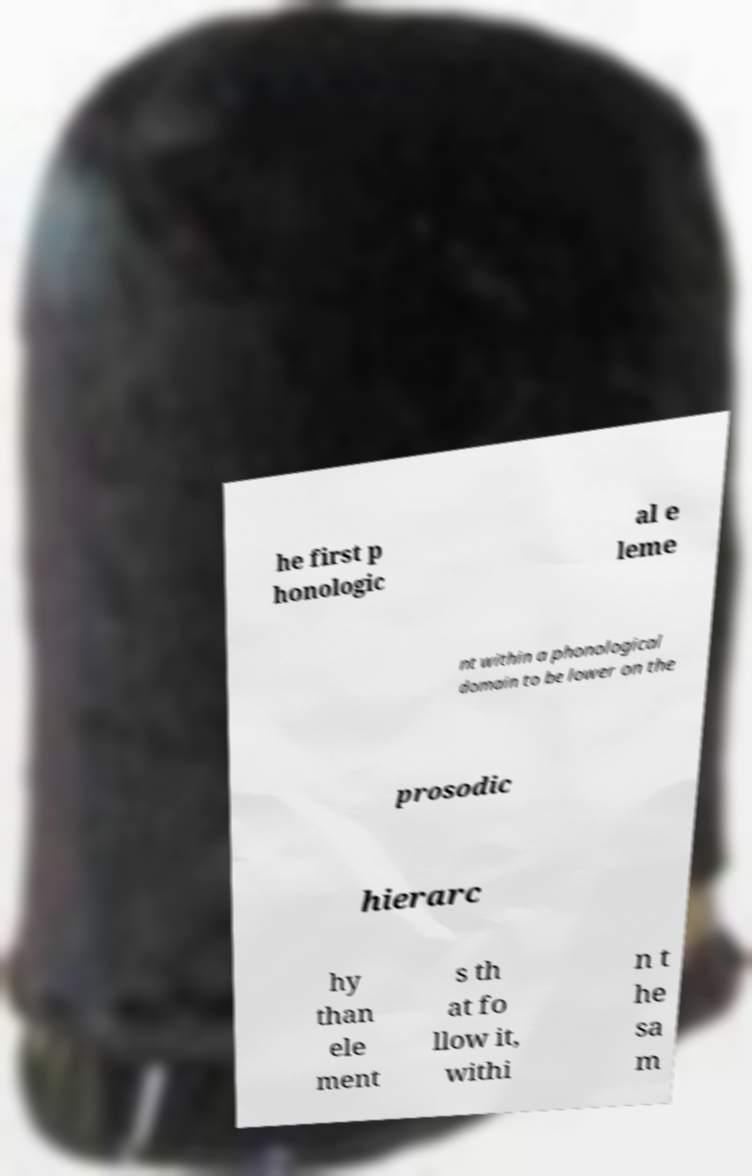There's text embedded in this image that I need extracted. Can you transcribe it verbatim? he first p honologic al e leme nt within a phonological domain to be lower on the prosodic hierarc hy than ele ment s th at fo llow it, withi n t he sa m 